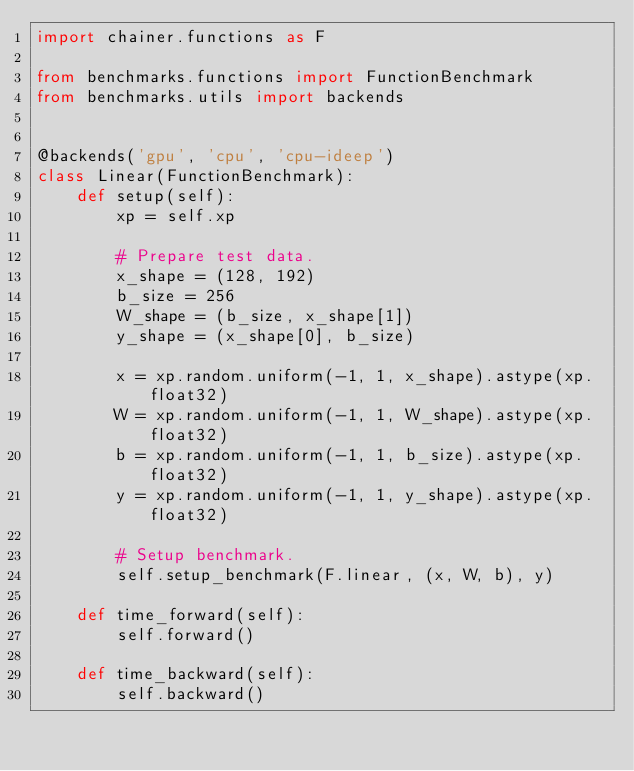Convert code to text. <code><loc_0><loc_0><loc_500><loc_500><_Python_>import chainer.functions as F

from benchmarks.functions import FunctionBenchmark
from benchmarks.utils import backends


@backends('gpu', 'cpu', 'cpu-ideep')
class Linear(FunctionBenchmark):
    def setup(self):
        xp = self.xp

        # Prepare test data.
        x_shape = (128, 192)
        b_size = 256
        W_shape = (b_size, x_shape[1])
        y_shape = (x_shape[0], b_size)

        x = xp.random.uniform(-1, 1, x_shape).astype(xp.float32)
        W = xp.random.uniform(-1, 1, W_shape).astype(xp.float32)
        b = xp.random.uniform(-1, 1, b_size).astype(xp.float32)
        y = xp.random.uniform(-1, 1, y_shape).astype(xp.float32)

        # Setup benchmark.
        self.setup_benchmark(F.linear, (x, W, b), y)

    def time_forward(self):
        self.forward()

    def time_backward(self):
        self.backward()
</code> 